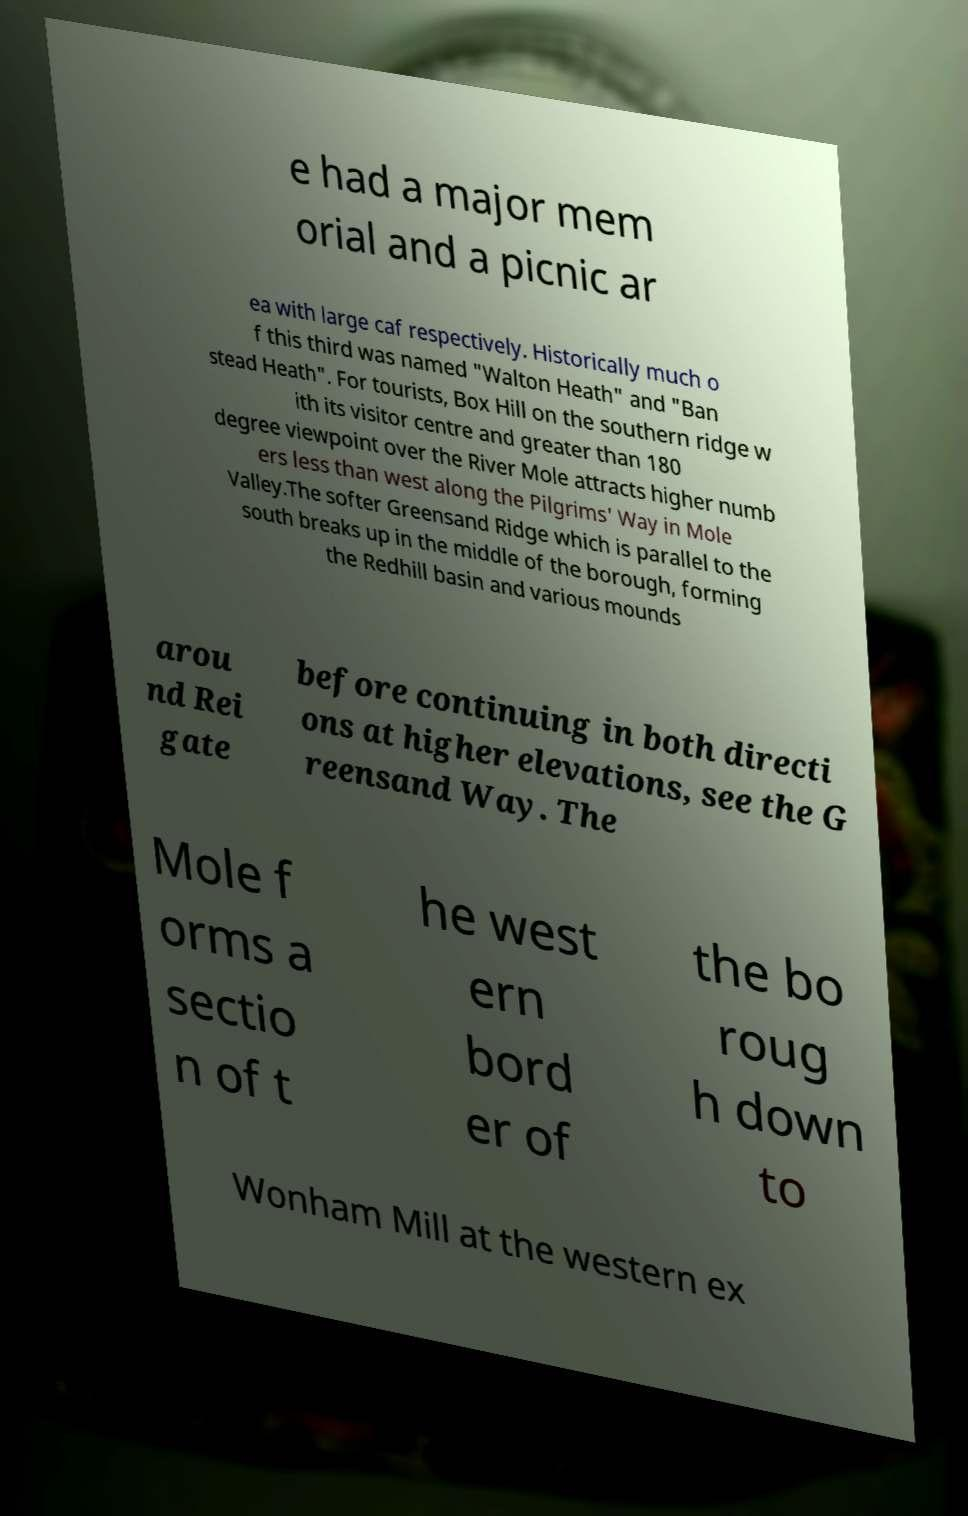Could you assist in decoding the text presented in this image and type it out clearly? e had a major mem orial and a picnic ar ea with large caf respectively. Historically much o f this third was named "Walton Heath" and "Ban stead Heath". For tourists, Box Hill on the southern ridge w ith its visitor centre and greater than 180 degree viewpoint over the River Mole attracts higher numb ers less than west along the Pilgrims' Way in Mole Valley.The softer Greensand Ridge which is parallel to the south breaks up in the middle of the borough, forming the Redhill basin and various mounds arou nd Rei gate before continuing in both directi ons at higher elevations, see the G reensand Way. The Mole f orms a sectio n of t he west ern bord er of the bo roug h down to Wonham Mill at the western ex 